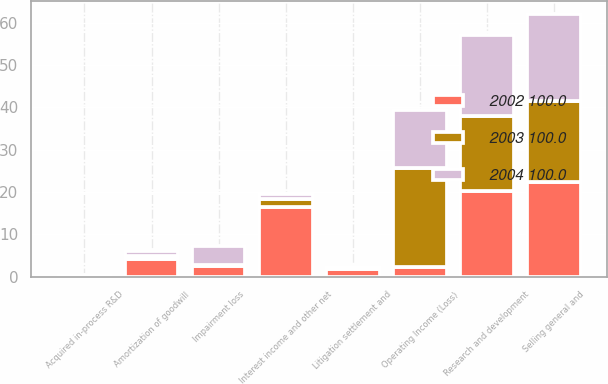Convert chart. <chart><loc_0><loc_0><loc_500><loc_500><stacked_bar_chart><ecel><fcel>Research and development<fcel>Selling general and<fcel>Amortization of goodwill<fcel>Impairment loss<fcel>Litigation settlement and<fcel>Acquired in-process R&D<fcel>Operating Income (Loss)<fcel>Interest income and other net<nl><fcel>2003 100.0<fcel>17.7<fcel>19.1<fcel>0.7<fcel>0.2<fcel>0.5<fcel>0.5<fcel>23.4<fcel>1.7<nl><fcel>2004 100.0<fcel>19.2<fcel>20.4<fcel>1.2<fcel>4.7<fcel>0<fcel>0<fcel>13.5<fcel>1.2<nl><fcel>2002 100.0<fcel>20.2<fcel>22.5<fcel>4.2<fcel>2.5<fcel>1.9<fcel>0<fcel>2.4<fcel>16.6<nl></chart> 